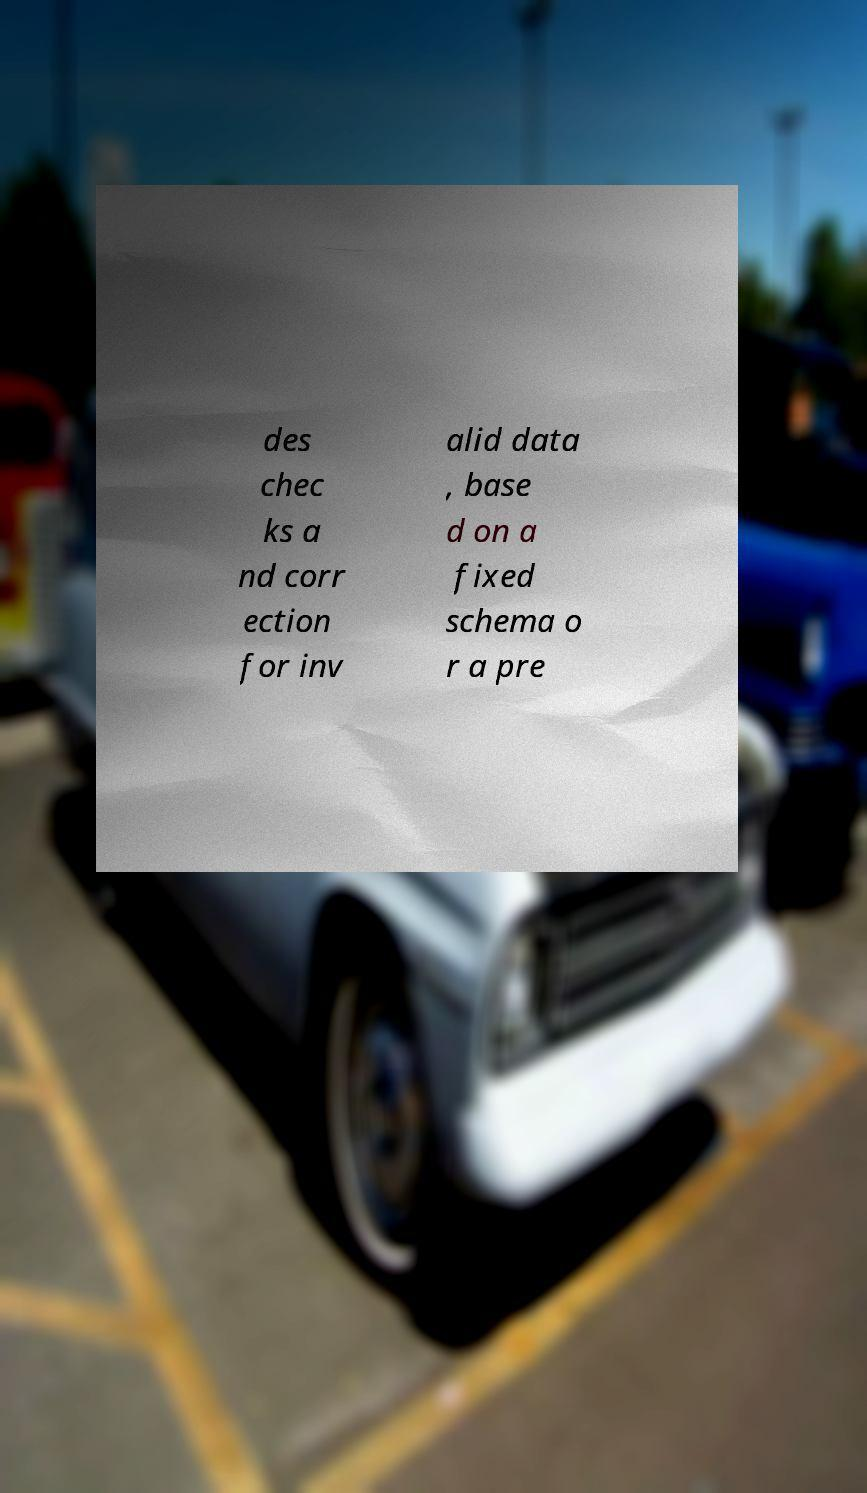Please read and relay the text visible in this image. What does it say? des chec ks a nd corr ection for inv alid data , base d on a fixed schema o r a pre 